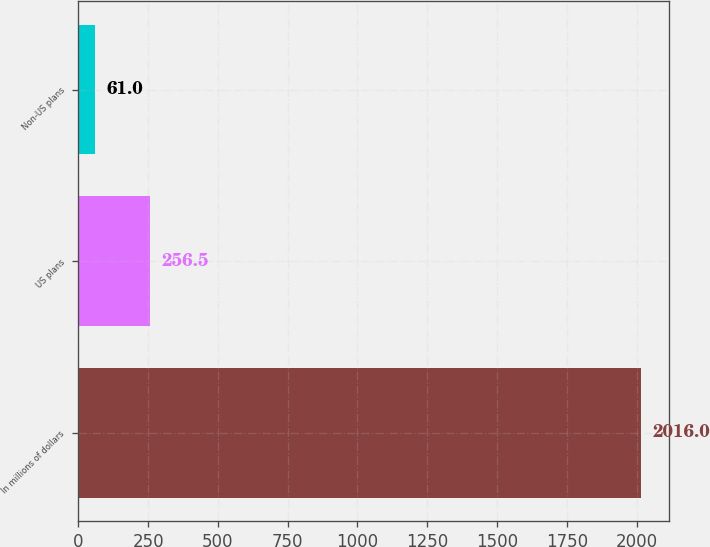<chart> <loc_0><loc_0><loc_500><loc_500><bar_chart><fcel>In millions of dollars<fcel>US plans<fcel>Non-US plans<nl><fcel>2016<fcel>256.5<fcel>61<nl></chart> 